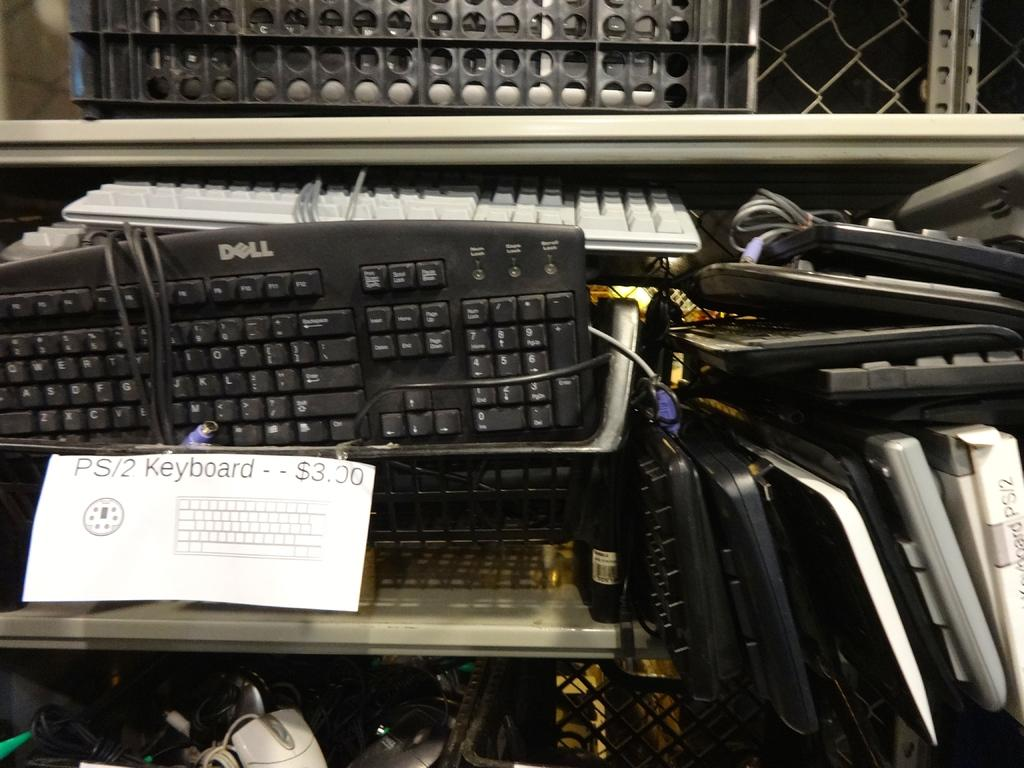Provide a one-sentence caption for the provided image. A bunch of old keyboards for sale at a used store. 